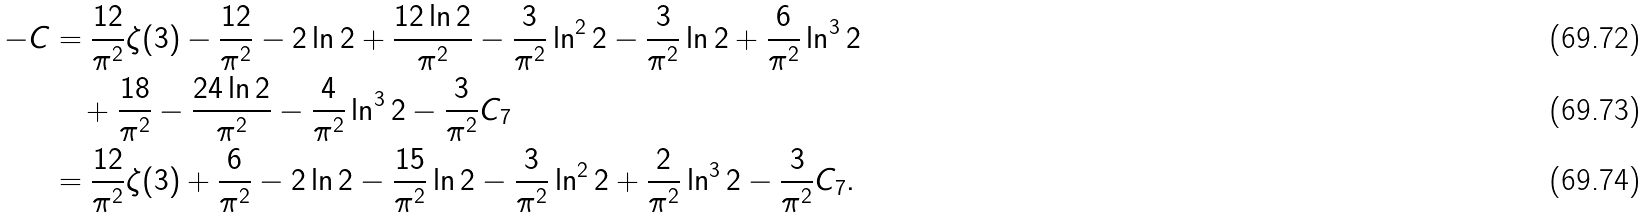Convert formula to latex. <formula><loc_0><loc_0><loc_500><loc_500>- C & = \frac { 1 2 } { \pi ^ { 2 } } \zeta ( 3 ) - \frac { 1 2 } { \pi ^ { 2 } } - 2 \ln 2 + \frac { 1 2 \ln 2 } { \pi ^ { 2 } } - \frac { 3 } { \pi ^ { 2 } } \ln ^ { 2 } 2 - \frac { 3 } { \pi ^ { 2 } } \ln 2 + \frac { 6 } { \pi ^ { 2 } } \ln ^ { 3 } 2 \\ & \quad + \frac { 1 8 } { \pi ^ { 2 } } - \frac { 2 4 \ln 2 } { \pi ^ { 2 } } - \frac { 4 } { \pi ^ { 2 } } \ln ^ { 3 } 2 - \frac { 3 } { \pi ^ { 2 } } C _ { 7 } \\ & = \frac { 1 2 } { \pi ^ { 2 } } \zeta ( 3 ) + \frac { 6 } { \pi ^ { 2 } } - 2 \ln 2 - \frac { 1 5 } { \pi ^ { 2 } } \ln 2 - \frac { 3 } { \pi ^ { 2 } } \ln ^ { 2 } 2 + \frac { 2 } { \pi ^ { 2 } } \ln ^ { 3 } 2 - \frac { 3 } { \pi ^ { 2 } } C _ { 7 } .</formula> 